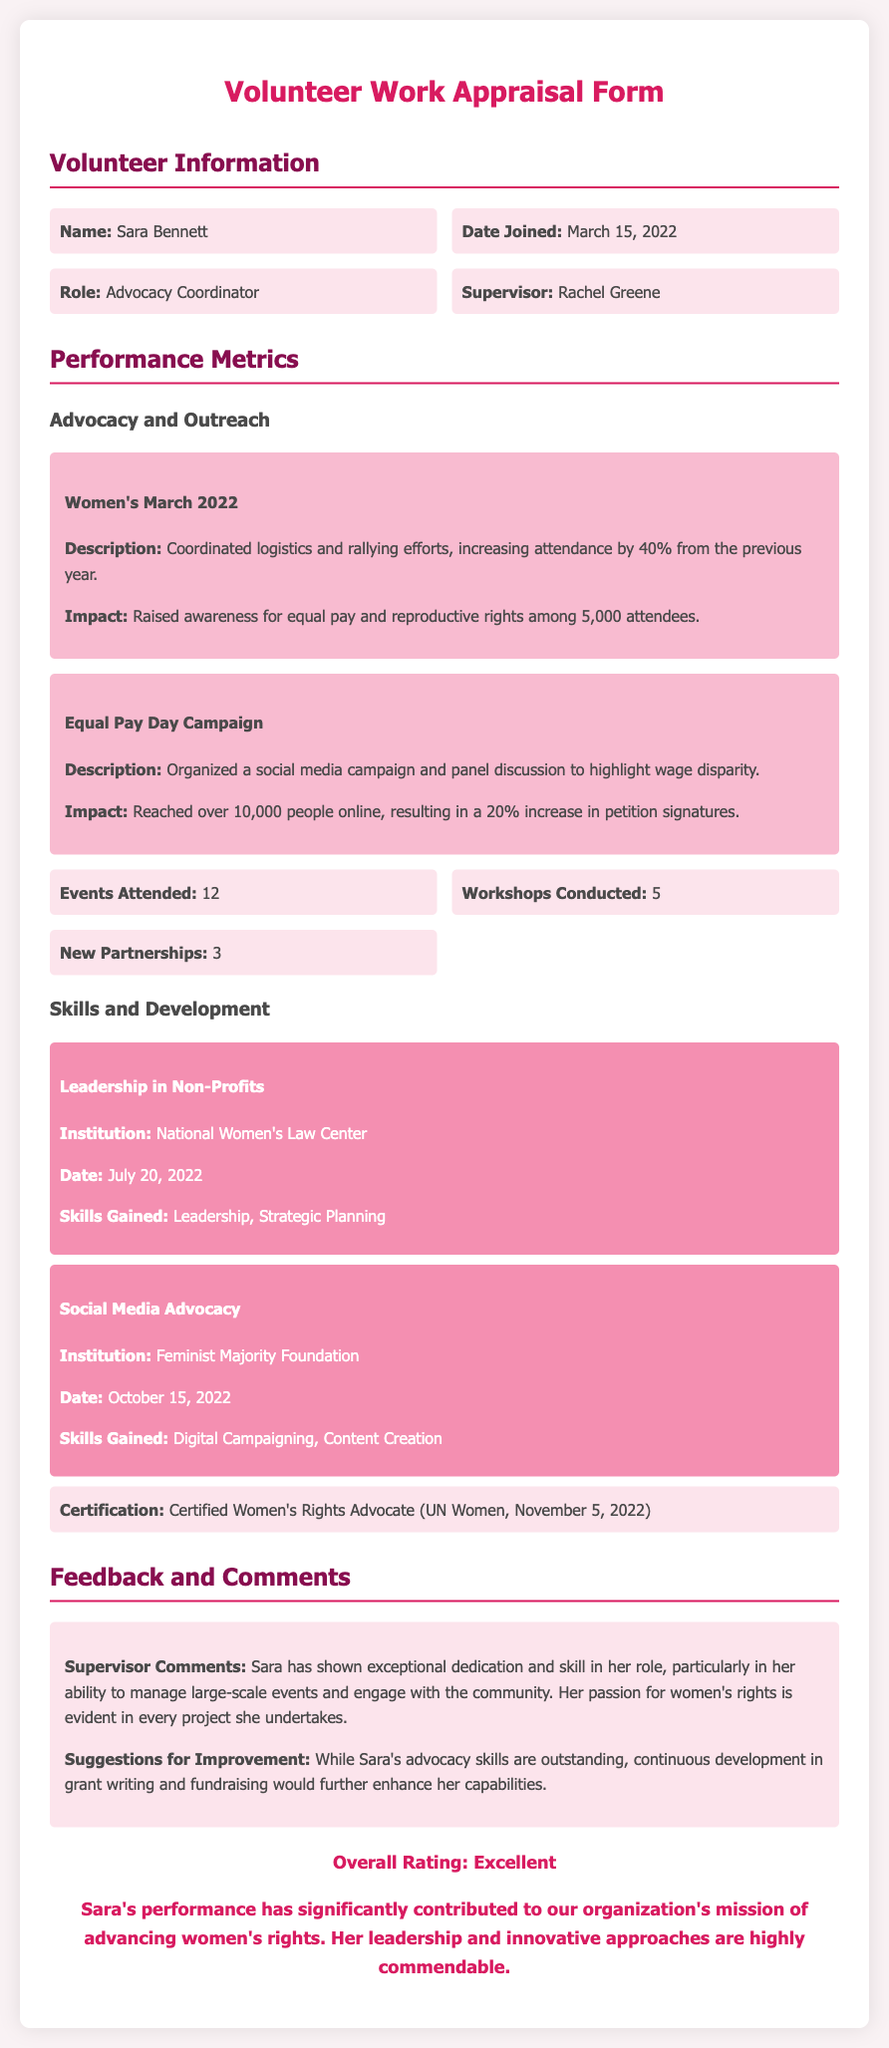What is the name of the volunteer? The document specifies the name of the volunteer as Sara Bennett.
Answer: Sara Bennett When did Sara join the organization? The date Sara joined is mentioned in the document as March 15, 2022.
Answer: March 15, 2022 What was Sara's role in the organization? The document states that Sara's role is Advocacy Coordinator.
Answer: Advocacy Coordinator How many events did Sara attend? The document specifies that Sara attended 12 events.
Answer: 12 What is the total number of workshops conducted by Sara? According to the document, Sara conducted 5 workshops.
Answer: 5 Which organization did Sara receive her Leadership training from? The document mentions that Sara's Leadership training was from the National Women's Law Center.
Answer: National Women's Law Center What was the impact of the Women’s March 2022 coordinated by Sara? The document indicates the impact was raising awareness for equal pay and reproductive rights among 5,000 attendees.
Answer: 5,000 attendees What is the overall rating of Sara's performance? The document concludes that Sara's overall rating is Excellent.
Answer: Excellent What skill is suggested for further improvement in Sara's role? The document suggests that grant writing and fundraising skills should be improved.
Answer: Grant writing and fundraising 